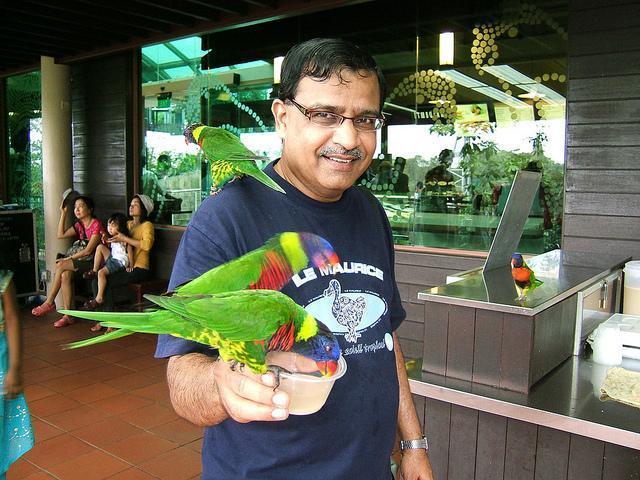How many birds is this man holding?
Give a very brief answer. 2. How many people are sitting in the background?
Give a very brief answer. 3. How many birds are in the picture?
Give a very brief answer. 3. How many people are there?
Give a very brief answer. 5. 